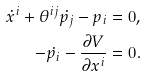<formula> <loc_0><loc_0><loc_500><loc_500>\dot { x } ^ { i } + \theta ^ { i j } \dot { p _ { j } } - p _ { i } = 0 , \\ - \dot { p _ { i } } - \frac { \partial V } { \partial x ^ { i } } = 0 .</formula> 